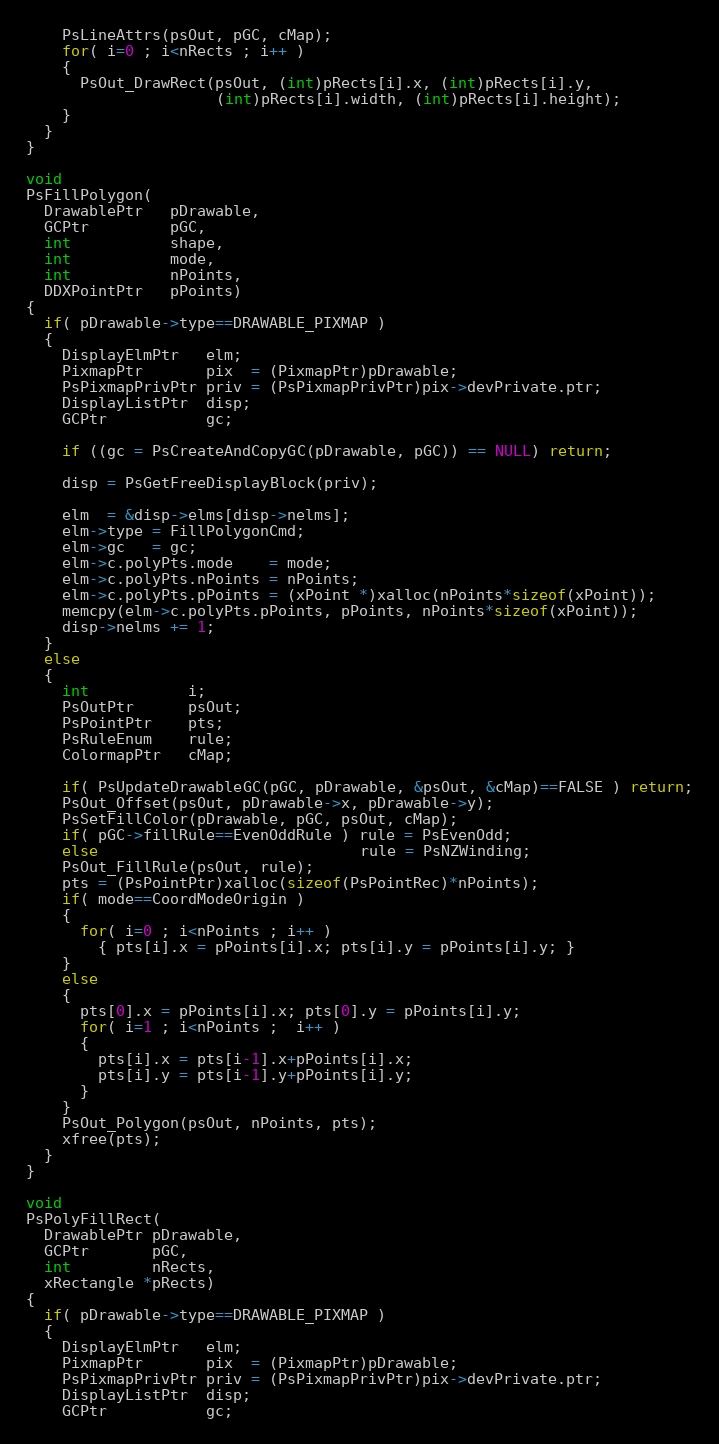<code> <loc_0><loc_0><loc_500><loc_500><_C_>    PsLineAttrs(psOut, pGC, cMap);
    for( i=0 ; i<nRects ; i++ )
    {
      PsOut_DrawRect(psOut, (int)pRects[i].x, (int)pRects[i].y,
                     (int)pRects[i].width, (int)pRects[i].height);
    }
  }
}

void
PsFillPolygon(
  DrawablePtr   pDrawable,
  GCPtr         pGC,
  int           shape,
  int           mode,
  int           nPoints,
  DDXPointPtr   pPoints)
{
  if( pDrawable->type==DRAWABLE_PIXMAP )
  {
    DisplayElmPtr   elm;
    PixmapPtr       pix  = (PixmapPtr)pDrawable;
    PsPixmapPrivPtr priv = (PsPixmapPrivPtr)pix->devPrivate.ptr;
    DisplayListPtr  disp;
    GCPtr           gc;

    if ((gc = PsCreateAndCopyGC(pDrawable, pGC)) == NULL) return;

    disp = PsGetFreeDisplayBlock(priv);

    elm  = &disp->elms[disp->nelms];
    elm->type = FillPolygonCmd;
    elm->gc   = gc;
    elm->c.polyPts.mode    = mode;
    elm->c.polyPts.nPoints = nPoints;
    elm->c.polyPts.pPoints = (xPoint *)xalloc(nPoints*sizeof(xPoint));
    memcpy(elm->c.polyPts.pPoints, pPoints, nPoints*sizeof(xPoint));
    disp->nelms += 1;
  }
  else
  {
    int           i;
    PsOutPtr      psOut;
    PsPointPtr    pts;
    PsRuleEnum    rule;
    ColormapPtr   cMap;

    if( PsUpdateDrawableGC(pGC, pDrawable, &psOut, &cMap)==FALSE ) return;
    PsOut_Offset(psOut, pDrawable->x, pDrawable->y);
    PsSetFillColor(pDrawable, pGC, psOut, cMap);
    if( pGC->fillRule==EvenOddRule ) rule = PsEvenOdd;
    else                             rule = PsNZWinding;
    PsOut_FillRule(psOut, rule);
    pts = (PsPointPtr)xalloc(sizeof(PsPointRec)*nPoints);
    if( mode==CoordModeOrigin )
    {
      for( i=0 ; i<nPoints ; i++ )
        { pts[i].x = pPoints[i].x; pts[i].y = pPoints[i].y; }
    }
    else
    {
      pts[0].x = pPoints[i].x; pts[0].y = pPoints[i].y;
      for( i=1 ; i<nPoints ;  i++ )
      {
        pts[i].x = pts[i-1].x+pPoints[i].x;
        pts[i].y = pts[i-1].y+pPoints[i].y;
      }
    }
    PsOut_Polygon(psOut, nPoints, pts);
    xfree(pts);
  }
}

void
PsPolyFillRect(
  DrawablePtr pDrawable,
  GCPtr       pGC,
  int         nRects,
  xRectangle *pRects)
{
  if( pDrawable->type==DRAWABLE_PIXMAP )
  {
    DisplayElmPtr   elm;
    PixmapPtr       pix  = (PixmapPtr)pDrawable;
    PsPixmapPrivPtr priv = (PsPixmapPrivPtr)pix->devPrivate.ptr;
    DisplayListPtr  disp;
    GCPtr           gc;
</code> 